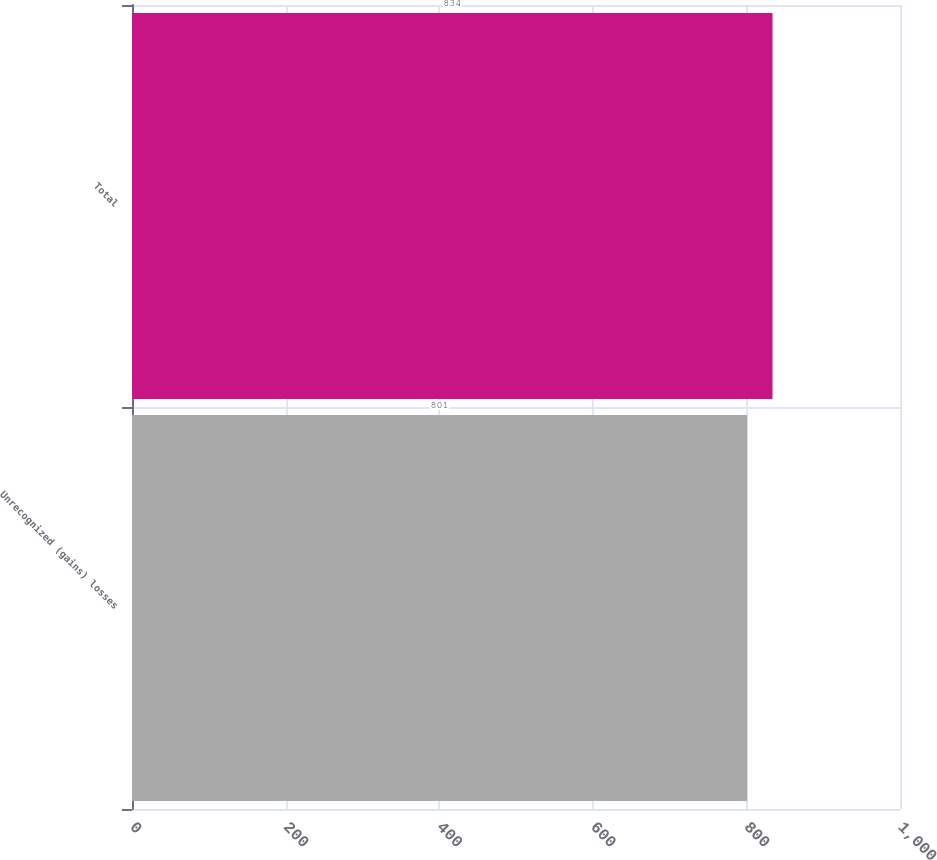Convert chart. <chart><loc_0><loc_0><loc_500><loc_500><bar_chart><fcel>Unrecognized (gains) losses<fcel>Total<nl><fcel>801<fcel>834<nl></chart> 